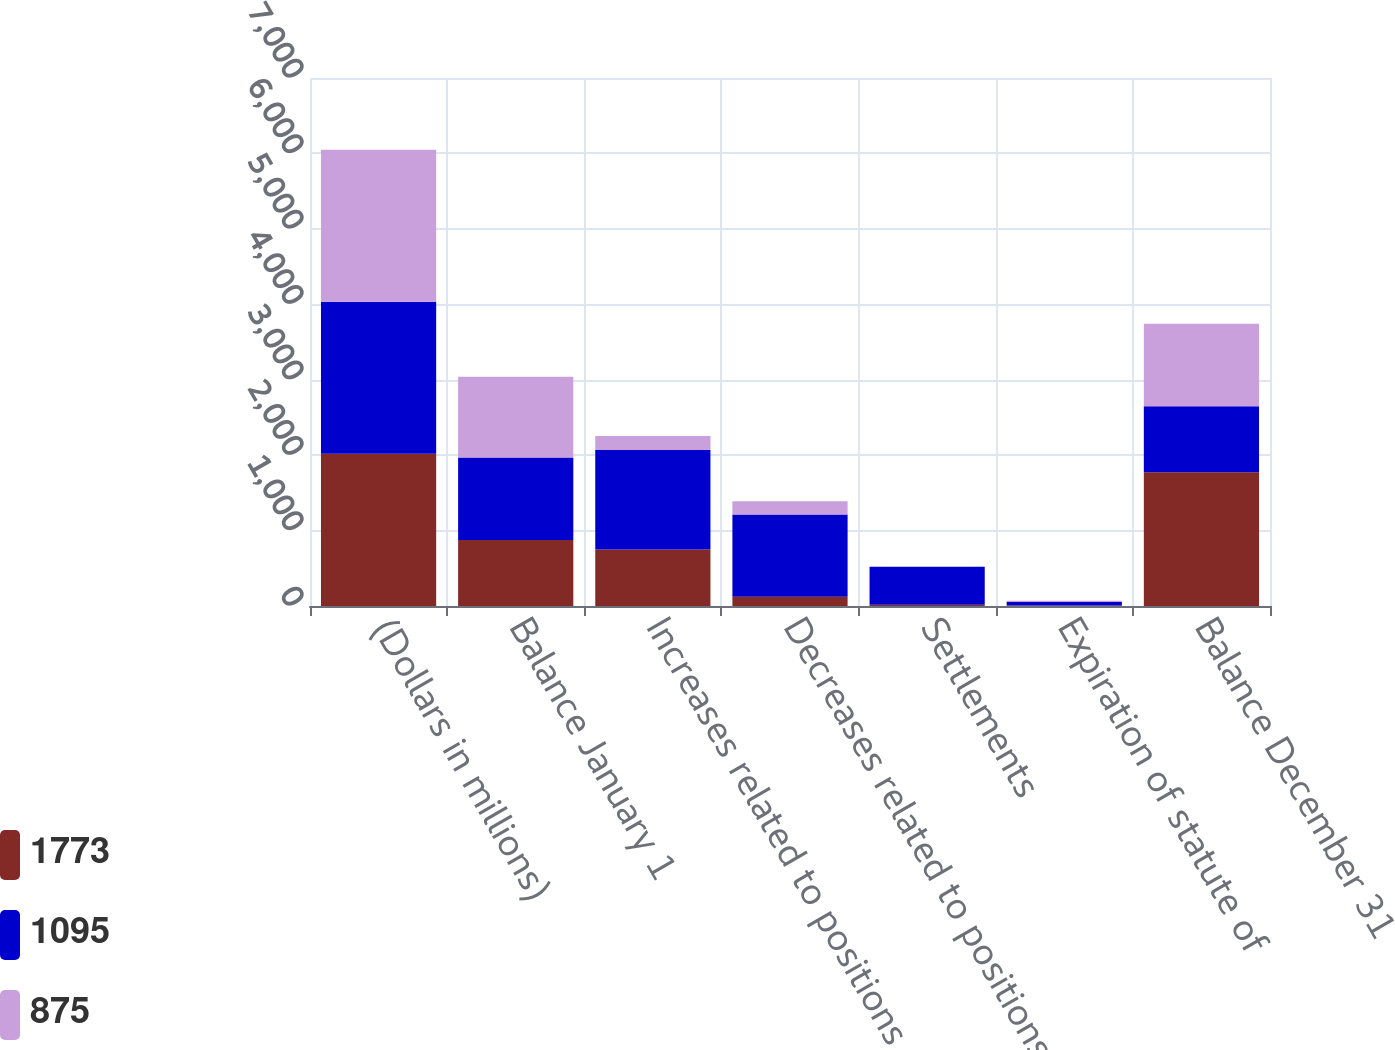<chart> <loc_0><loc_0><loc_500><loc_500><stacked_bar_chart><ecel><fcel>(Dollars in millions)<fcel>Balance January 1<fcel>Increases related to positions<fcel>Decreases related to positions<fcel>Settlements<fcel>Expiration of statute of<fcel>Balance December 31<nl><fcel>1773<fcel>2017<fcel>875<fcel>750<fcel>122<fcel>17<fcel>5<fcel>1773<nl><fcel>1095<fcel>2016<fcel>1095<fcel>1318<fcel>1091<fcel>503<fcel>48<fcel>875<nl><fcel>875<fcel>2015<fcel>1068<fcel>187<fcel>177<fcel>1<fcel>18<fcel>1095<nl></chart> 